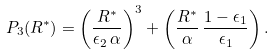Convert formula to latex. <formula><loc_0><loc_0><loc_500><loc_500>P _ { 3 } ( R ^ { * } ) = \left ( \frac { R ^ { * } } { \epsilon _ { 2 } \, \alpha } \right ) ^ { 3 } + \left ( \frac { R ^ { * } } { \alpha } \, \frac { 1 - \epsilon _ { 1 } } { \epsilon _ { 1 } } \right ) .</formula> 